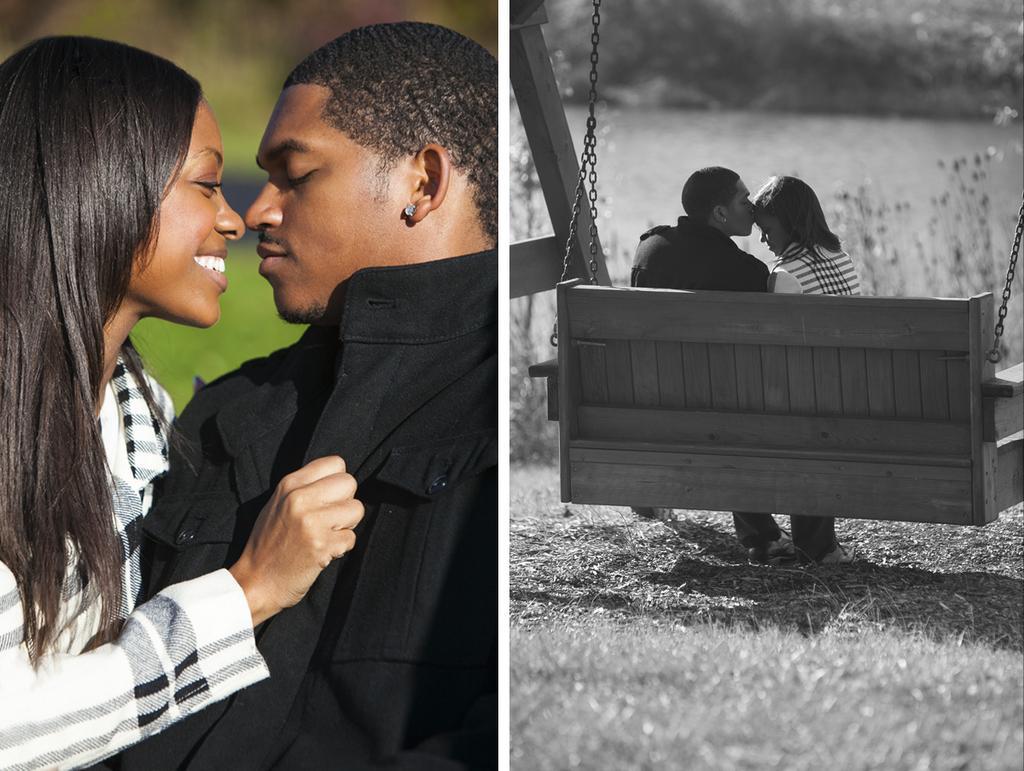In one or two sentences, can you explain what this image depicts? In this image I can see a person wearing black dress and a woman wearing black and white dress are sitting on a wooden bench. I can see some grass and in the background I can see few plants and few trees. 